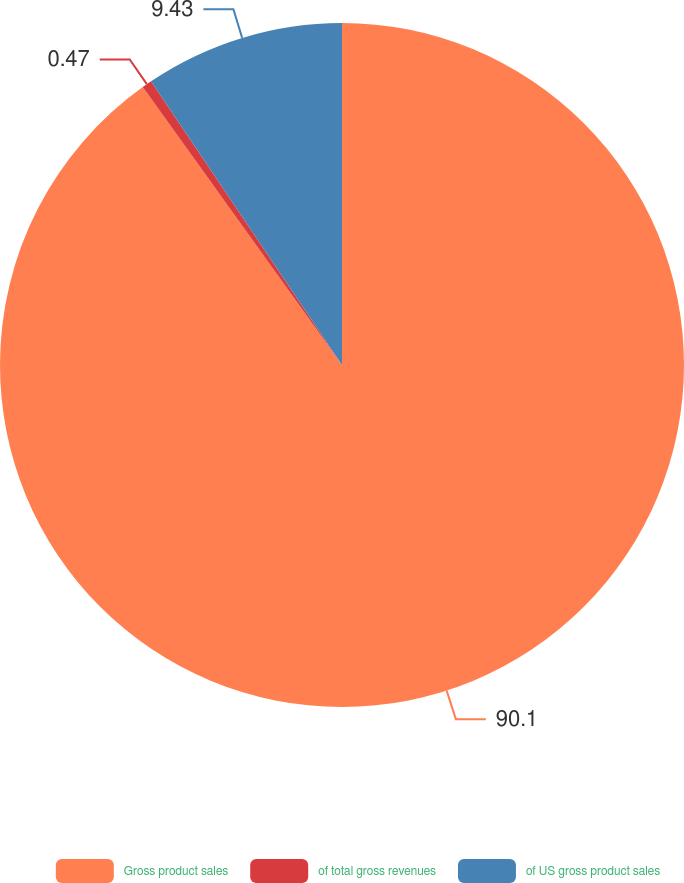Convert chart. <chart><loc_0><loc_0><loc_500><loc_500><pie_chart><fcel>Gross product sales<fcel>of total gross revenues<fcel>of US gross product sales<nl><fcel>90.1%<fcel>0.47%<fcel>9.43%<nl></chart> 